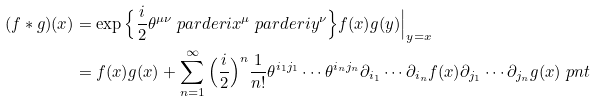Convert formula to latex. <formula><loc_0><loc_0><loc_500><loc_500>( f \ast g ) ( x ) & = \exp \Big \{ \frac { i } { 2 } \theta ^ { \mu \nu } \ p a r d e r i { x ^ { \mu } } \ p a r d e r i { y ^ { \nu } } \Big \} f ( x ) g ( y ) \Big | _ { y = x } \\ & = f ( x ) g ( x ) + \sum _ { n = 1 } ^ { \infty } \Big ( \frac { i } { 2 } \Big ) ^ { n } \frac { 1 } { n ! } \theta ^ { i _ { 1 } j _ { 1 } } \cdots \theta ^ { i _ { n } j _ { n } } \partial _ { i _ { 1 } } \cdots \partial _ { i _ { n } } f ( x ) \partial _ { j _ { 1 } } \cdots \partial _ { j _ { n } } g ( x ) \ p n t</formula> 